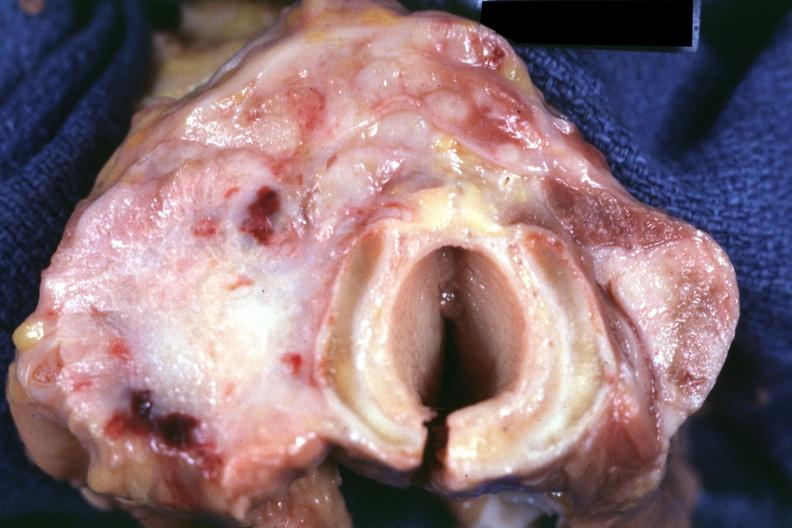what had colon carcinoma?
Answer the question using a single word or phrase. Section through thyroid and trachea 